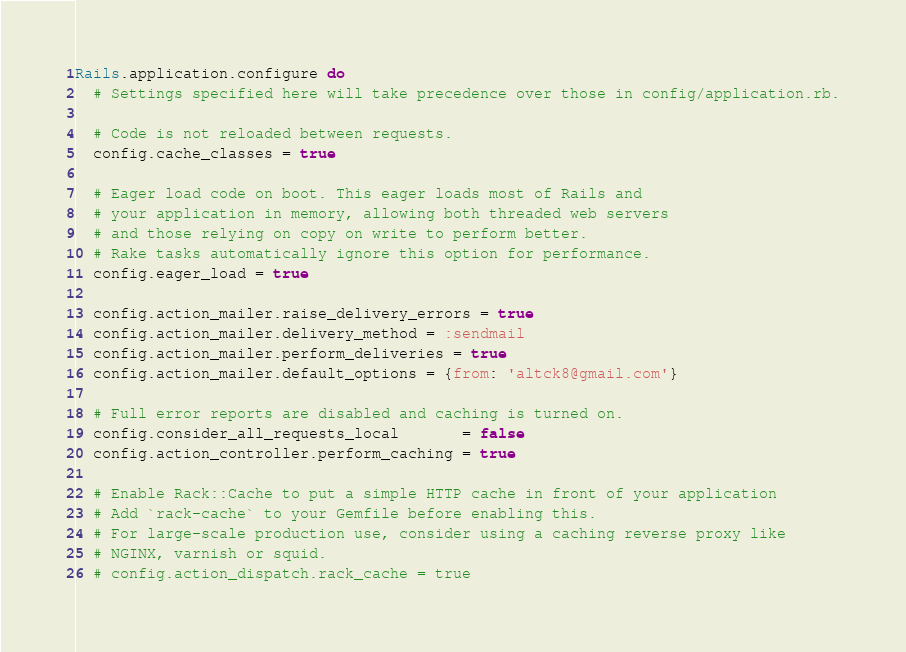<code> <loc_0><loc_0><loc_500><loc_500><_Ruby_>Rails.application.configure do
  # Settings specified here will take precedence over those in config/application.rb.

  # Code is not reloaded between requests.
  config.cache_classes = true

  # Eager load code on boot. This eager loads most of Rails and
  # your application in memory, allowing both threaded web servers
  # and those relying on copy on write to perform better.
  # Rake tasks automatically ignore this option for performance.
  config.eager_load = true

  config.action_mailer.raise_delivery_errors = true
  config.action_mailer.delivery_method = :sendmail
  config.action_mailer.perform_deliveries = true
  config.action_mailer.default_options = {from: 'altck8@gmail.com'}

  # Full error reports are disabled and caching is turned on.
  config.consider_all_requests_local       = false
  config.action_controller.perform_caching = true

  # Enable Rack::Cache to put a simple HTTP cache in front of your application
  # Add `rack-cache` to your Gemfile before enabling this.
  # For large-scale production use, consider using a caching reverse proxy like
  # NGINX, varnish or squid.
  # config.action_dispatch.rack_cache = true
</code> 